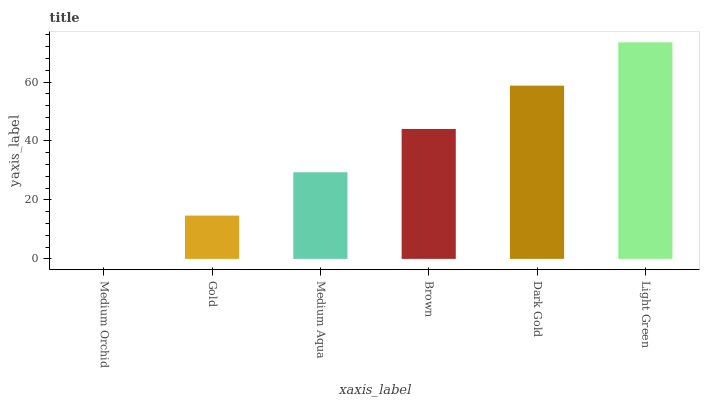Is Medium Orchid the minimum?
Answer yes or no. Yes. Is Light Green the maximum?
Answer yes or no. Yes. Is Gold the minimum?
Answer yes or no. No. Is Gold the maximum?
Answer yes or no. No. Is Gold greater than Medium Orchid?
Answer yes or no. Yes. Is Medium Orchid less than Gold?
Answer yes or no. Yes. Is Medium Orchid greater than Gold?
Answer yes or no. No. Is Gold less than Medium Orchid?
Answer yes or no. No. Is Brown the high median?
Answer yes or no. Yes. Is Medium Aqua the low median?
Answer yes or no. Yes. Is Gold the high median?
Answer yes or no. No. Is Gold the low median?
Answer yes or no. No. 